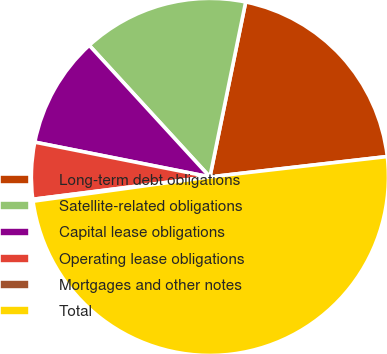Convert chart. <chart><loc_0><loc_0><loc_500><loc_500><pie_chart><fcel>Long-term debt obligations<fcel>Satellite-related obligations<fcel>Capital lease obligations<fcel>Operating lease obligations<fcel>Mortgages and other notes<fcel>Total<nl><fcel>19.97%<fcel>15.02%<fcel>10.07%<fcel>5.12%<fcel>0.17%<fcel>49.65%<nl></chart> 